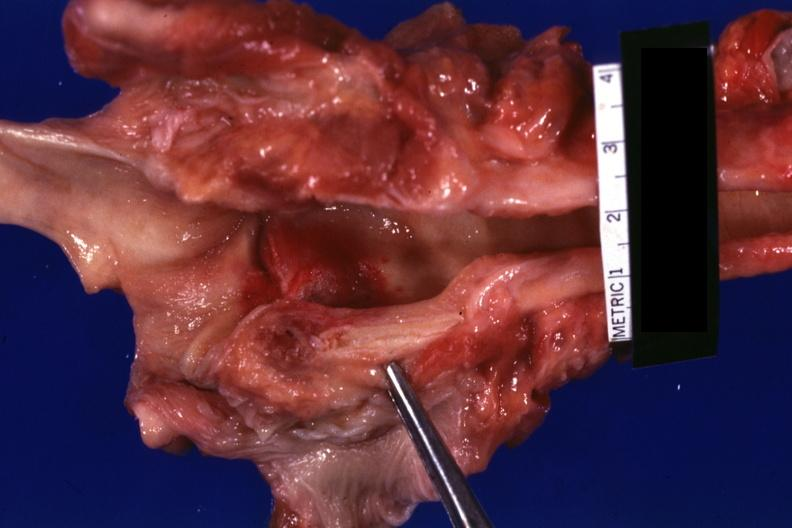what is present?
Answer the question using a single word or phrase. Larynx 